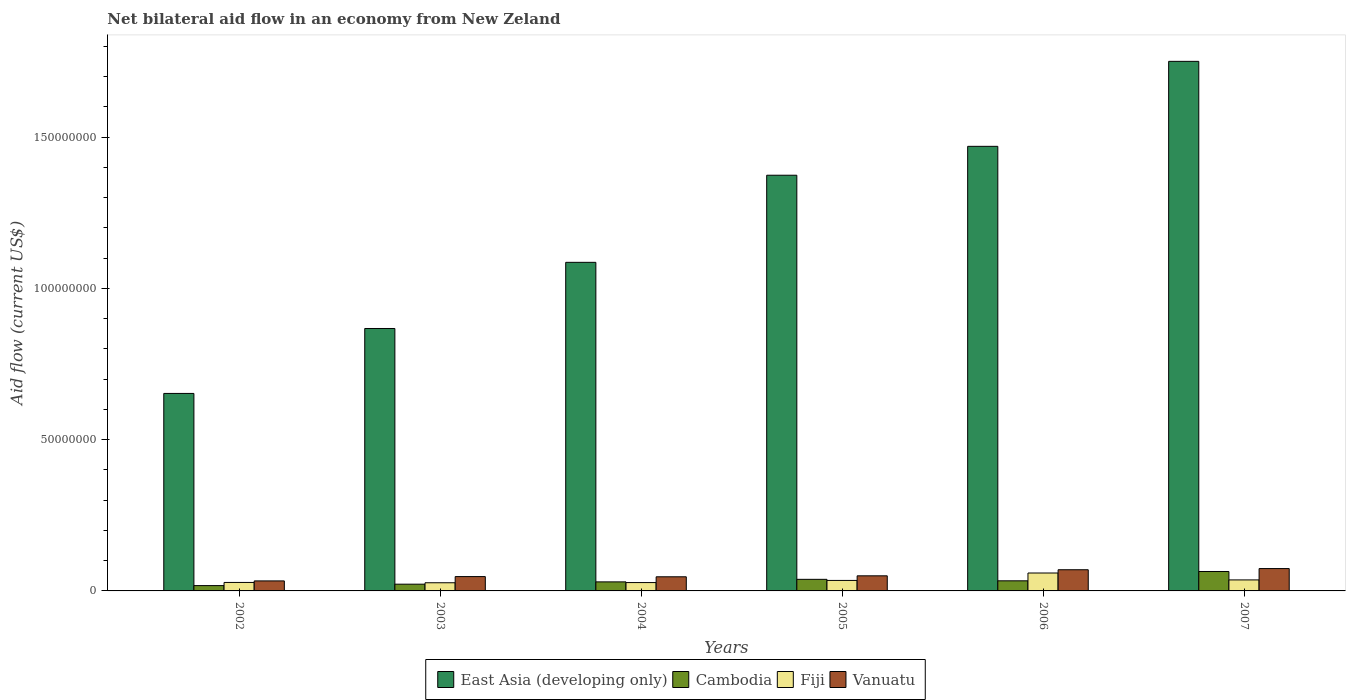How many different coloured bars are there?
Offer a very short reply. 4. How many bars are there on the 5th tick from the right?
Ensure brevity in your answer.  4. What is the label of the 4th group of bars from the left?
Provide a short and direct response. 2005. What is the net bilateral aid flow in Cambodia in 2002?
Your response must be concise. 1.76e+06. Across all years, what is the maximum net bilateral aid flow in East Asia (developing only)?
Ensure brevity in your answer.  1.75e+08. Across all years, what is the minimum net bilateral aid flow in Vanuatu?
Your answer should be very brief. 3.31e+06. In which year was the net bilateral aid flow in Fiji minimum?
Provide a succinct answer. 2003. What is the total net bilateral aid flow in Vanuatu in the graph?
Your answer should be compact. 3.21e+07. What is the difference between the net bilateral aid flow in Cambodia in 2003 and that in 2007?
Your answer should be compact. -4.19e+06. What is the difference between the net bilateral aid flow in East Asia (developing only) in 2002 and the net bilateral aid flow in Fiji in 2004?
Provide a short and direct response. 6.25e+07. What is the average net bilateral aid flow in East Asia (developing only) per year?
Your response must be concise. 1.20e+08. In how many years, is the net bilateral aid flow in Cambodia greater than 110000000 US$?
Your answer should be very brief. 0. What is the ratio of the net bilateral aid flow in East Asia (developing only) in 2002 to that in 2007?
Give a very brief answer. 0.37. What is the difference between the highest and the second highest net bilateral aid flow in East Asia (developing only)?
Give a very brief answer. 2.81e+07. What is the difference between the highest and the lowest net bilateral aid flow in Vanuatu?
Keep it short and to the point. 4.08e+06. In how many years, is the net bilateral aid flow in Fiji greater than the average net bilateral aid flow in Fiji taken over all years?
Keep it short and to the point. 2. Is the sum of the net bilateral aid flow in Cambodia in 2002 and 2003 greater than the maximum net bilateral aid flow in Fiji across all years?
Provide a short and direct response. No. What does the 3rd bar from the left in 2004 represents?
Give a very brief answer. Fiji. What does the 2nd bar from the right in 2007 represents?
Ensure brevity in your answer.  Fiji. How many bars are there?
Provide a succinct answer. 24. Are all the bars in the graph horizontal?
Ensure brevity in your answer.  No. What is the difference between two consecutive major ticks on the Y-axis?
Provide a succinct answer. 5.00e+07. Are the values on the major ticks of Y-axis written in scientific E-notation?
Your answer should be compact. No. Does the graph contain any zero values?
Ensure brevity in your answer.  No. Does the graph contain grids?
Your answer should be compact. No. How many legend labels are there?
Your answer should be compact. 4. What is the title of the graph?
Ensure brevity in your answer.  Net bilateral aid flow in an economy from New Zeland. What is the label or title of the X-axis?
Provide a succinct answer. Years. What is the Aid flow (current US$) of East Asia (developing only) in 2002?
Your response must be concise. 6.53e+07. What is the Aid flow (current US$) of Cambodia in 2002?
Your response must be concise. 1.76e+06. What is the Aid flow (current US$) of Fiji in 2002?
Give a very brief answer. 2.80e+06. What is the Aid flow (current US$) in Vanuatu in 2002?
Offer a terse response. 3.31e+06. What is the Aid flow (current US$) in East Asia (developing only) in 2003?
Your answer should be compact. 8.67e+07. What is the Aid flow (current US$) in Cambodia in 2003?
Your answer should be very brief. 2.23e+06. What is the Aid flow (current US$) of Fiji in 2003?
Your answer should be very brief. 2.70e+06. What is the Aid flow (current US$) in Vanuatu in 2003?
Your answer should be compact. 4.74e+06. What is the Aid flow (current US$) in East Asia (developing only) in 2004?
Give a very brief answer. 1.09e+08. What is the Aid flow (current US$) of Cambodia in 2004?
Provide a succinct answer. 2.99e+06. What is the Aid flow (current US$) of Fiji in 2004?
Your answer should be compact. 2.76e+06. What is the Aid flow (current US$) in Vanuatu in 2004?
Your answer should be very brief. 4.67e+06. What is the Aid flow (current US$) in East Asia (developing only) in 2005?
Make the answer very short. 1.37e+08. What is the Aid flow (current US$) of Cambodia in 2005?
Your answer should be very brief. 3.83e+06. What is the Aid flow (current US$) of Fiji in 2005?
Provide a short and direct response. 3.47e+06. What is the Aid flow (current US$) of Vanuatu in 2005?
Offer a terse response. 4.99e+06. What is the Aid flow (current US$) of East Asia (developing only) in 2006?
Your answer should be compact. 1.47e+08. What is the Aid flow (current US$) in Cambodia in 2006?
Your response must be concise. 3.34e+06. What is the Aid flow (current US$) of Fiji in 2006?
Make the answer very short. 5.92e+06. What is the Aid flow (current US$) in Vanuatu in 2006?
Give a very brief answer. 7.00e+06. What is the Aid flow (current US$) in East Asia (developing only) in 2007?
Give a very brief answer. 1.75e+08. What is the Aid flow (current US$) in Cambodia in 2007?
Offer a terse response. 6.42e+06. What is the Aid flow (current US$) in Fiji in 2007?
Offer a terse response. 3.64e+06. What is the Aid flow (current US$) in Vanuatu in 2007?
Offer a terse response. 7.39e+06. Across all years, what is the maximum Aid flow (current US$) of East Asia (developing only)?
Offer a terse response. 1.75e+08. Across all years, what is the maximum Aid flow (current US$) of Cambodia?
Give a very brief answer. 6.42e+06. Across all years, what is the maximum Aid flow (current US$) of Fiji?
Your answer should be compact. 5.92e+06. Across all years, what is the maximum Aid flow (current US$) in Vanuatu?
Your answer should be compact. 7.39e+06. Across all years, what is the minimum Aid flow (current US$) in East Asia (developing only)?
Provide a succinct answer. 6.53e+07. Across all years, what is the minimum Aid flow (current US$) of Cambodia?
Your response must be concise. 1.76e+06. Across all years, what is the minimum Aid flow (current US$) in Fiji?
Make the answer very short. 2.70e+06. Across all years, what is the minimum Aid flow (current US$) in Vanuatu?
Offer a terse response. 3.31e+06. What is the total Aid flow (current US$) of East Asia (developing only) in the graph?
Provide a succinct answer. 7.20e+08. What is the total Aid flow (current US$) in Cambodia in the graph?
Your response must be concise. 2.06e+07. What is the total Aid flow (current US$) in Fiji in the graph?
Provide a short and direct response. 2.13e+07. What is the total Aid flow (current US$) in Vanuatu in the graph?
Your answer should be compact. 3.21e+07. What is the difference between the Aid flow (current US$) of East Asia (developing only) in 2002 and that in 2003?
Provide a succinct answer. -2.15e+07. What is the difference between the Aid flow (current US$) in Cambodia in 2002 and that in 2003?
Make the answer very short. -4.70e+05. What is the difference between the Aid flow (current US$) in Vanuatu in 2002 and that in 2003?
Ensure brevity in your answer.  -1.43e+06. What is the difference between the Aid flow (current US$) of East Asia (developing only) in 2002 and that in 2004?
Provide a succinct answer. -4.33e+07. What is the difference between the Aid flow (current US$) in Cambodia in 2002 and that in 2004?
Provide a short and direct response. -1.23e+06. What is the difference between the Aid flow (current US$) in Vanuatu in 2002 and that in 2004?
Ensure brevity in your answer.  -1.36e+06. What is the difference between the Aid flow (current US$) in East Asia (developing only) in 2002 and that in 2005?
Provide a succinct answer. -7.21e+07. What is the difference between the Aid flow (current US$) of Cambodia in 2002 and that in 2005?
Ensure brevity in your answer.  -2.07e+06. What is the difference between the Aid flow (current US$) of Fiji in 2002 and that in 2005?
Give a very brief answer. -6.70e+05. What is the difference between the Aid flow (current US$) of Vanuatu in 2002 and that in 2005?
Offer a terse response. -1.68e+06. What is the difference between the Aid flow (current US$) in East Asia (developing only) in 2002 and that in 2006?
Your answer should be compact. -8.17e+07. What is the difference between the Aid flow (current US$) of Cambodia in 2002 and that in 2006?
Your answer should be very brief. -1.58e+06. What is the difference between the Aid flow (current US$) of Fiji in 2002 and that in 2006?
Provide a short and direct response. -3.12e+06. What is the difference between the Aid flow (current US$) in Vanuatu in 2002 and that in 2006?
Ensure brevity in your answer.  -3.69e+06. What is the difference between the Aid flow (current US$) in East Asia (developing only) in 2002 and that in 2007?
Ensure brevity in your answer.  -1.10e+08. What is the difference between the Aid flow (current US$) of Cambodia in 2002 and that in 2007?
Provide a short and direct response. -4.66e+06. What is the difference between the Aid flow (current US$) in Fiji in 2002 and that in 2007?
Offer a very short reply. -8.40e+05. What is the difference between the Aid flow (current US$) in Vanuatu in 2002 and that in 2007?
Ensure brevity in your answer.  -4.08e+06. What is the difference between the Aid flow (current US$) of East Asia (developing only) in 2003 and that in 2004?
Make the answer very short. -2.19e+07. What is the difference between the Aid flow (current US$) of Cambodia in 2003 and that in 2004?
Make the answer very short. -7.60e+05. What is the difference between the Aid flow (current US$) of Fiji in 2003 and that in 2004?
Ensure brevity in your answer.  -6.00e+04. What is the difference between the Aid flow (current US$) in East Asia (developing only) in 2003 and that in 2005?
Provide a succinct answer. -5.07e+07. What is the difference between the Aid flow (current US$) of Cambodia in 2003 and that in 2005?
Offer a very short reply. -1.60e+06. What is the difference between the Aid flow (current US$) of Fiji in 2003 and that in 2005?
Your answer should be compact. -7.70e+05. What is the difference between the Aid flow (current US$) of East Asia (developing only) in 2003 and that in 2006?
Provide a short and direct response. -6.02e+07. What is the difference between the Aid flow (current US$) of Cambodia in 2003 and that in 2006?
Offer a terse response. -1.11e+06. What is the difference between the Aid flow (current US$) of Fiji in 2003 and that in 2006?
Offer a terse response. -3.22e+06. What is the difference between the Aid flow (current US$) of Vanuatu in 2003 and that in 2006?
Keep it short and to the point. -2.26e+06. What is the difference between the Aid flow (current US$) in East Asia (developing only) in 2003 and that in 2007?
Offer a terse response. -8.83e+07. What is the difference between the Aid flow (current US$) of Cambodia in 2003 and that in 2007?
Offer a very short reply. -4.19e+06. What is the difference between the Aid flow (current US$) in Fiji in 2003 and that in 2007?
Keep it short and to the point. -9.40e+05. What is the difference between the Aid flow (current US$) of Vanuatu in 2003 and that in 2007?
Your answer should be very brief. -2.65e+06. What is the difference between the Aid flow (current US$) of East Asia (developing only) in 2004 and that in 2005?
Your answer should be compact. -2.88e+07. What is the difference between the Aid flow (current US$) of Cambodia in 2004 and that in 2005?
Give a very brief answer. -8.40e+05. What is the difference between the Aid flow (current US$) in Fiji in 2004 and that in 2005?
Provide a succinct answer. -7.10e+05. What is the difference between the Aid flow (current US$) in Vanuatu in 2004 and that in 2005?
Ensure brevity in your answer.  -3.20e+05. What is the difference between the Aid flow (current US$) of East Asia (developing only) in 2004 and that in 2006?
Give a very brief answer. -3.83e+07. What is the difference between the Aid flow (current US$) of Cambodia in 2004 and that in 2006?
Your response must be concise. -3.50e+05. What is the difference between the Aid flow (current US$) of Fiji in 2004 and that in 2006?
Offer a terse response. -3.16e+06. What is the difference between the Aid flow (current US$) of Vanuatu in 2004 and that in 2006?
Give a very brief answer. -2.33e+06. What is the difference between the Aid flow (current US$) of East Asia (developing only) in 2004 and that in 2007?
Offer a terse response. -6.64e+07. What is the difference between the Aid flow (current US$) in Cambodia in 2004 and that in 2007?
Provide a succinct answer. -3.43e+06. What is the difference between the Aid flow (current US$) of Fiji in 2004 and that in 2007?
Offer a very short reply. -8.80e+05. What is the difference between the Aid flow (current US$) of Vanuatu in 2004 and that in 2007?
Give a very brief answer. -2.72e+06. What is the difference between the Aid flow (current US$) of East Asia (developing only) in 2005 and that in 2006?
Your response must be concise. -9.55e+06. What is the difference between the Aid flow (current US$) in Cambodia in 2005 and that in 2006?
Offer a very short reply. 4.90e+05. What is the difference between the Aid flow (current US$) of Fiji in 2005 and that in 2006?
Your response must be concise. -2.45e+06. What is the difference between the Aid flow (current US$) of Vanuatu in 2005 and that in 2006?
Offer a very short reply. -2.01e+06. What is the difference between the Aid flow (current US$) in East Asia (developing only) in 2005 and that in 2007?
Your response must be concise. -3.76e+07. What is the difference between the Aid flow (current US$) in Cambodia in 2005 and that in 2007?
Your answer should be compact. -2.59e+06. What is the difference between the Aid flow (current US$) of Fiji in 2005 and that in 2007?
Your answer should be compact. -1.70e+05. What is the difference between the Aid flow (current US$) in Vanuatu in 2005 and that in 2007?
Your response must be concise. -2.40e+06. What is the difference between the Aid flow (current US$) in East Asia (developing only) in 2006 and that in 2007?
Give a very brief answer. -2.81e+07. What is the difference between the Aid flow (current US$) of Cambodia in 2006 and that in 2007?
Your answer should be compact. -3.08e+06. What is the difference between the Aid flow (current US$) of Fiji in 2006 and that in 2007?
Give a very brief answer. 2.28e+06. What is the difference between the Aid flow (current US$) in Vanuatu in 2006 and that in 2007?
Your response must be concise. -3.90e+05. What is the difference between the Aid flow (current US$) of East Asia (developing only) in 2002 and the Aid flow (current US$) of Cambodia in 2003?
Your answer should be compact. 6.30e+07. What is the difference between the Aid flow (current US$) of East Asia (developing only) in 2002 and the Aid flow (current US$) of Fiji in 2003?
Your answer should be very brief. 6.26e+07. What is the difference between the Aid flow (current US$) of East Asia (developing only) in 2002 and the Aid flow (current US$) of Vanuatu in 2003?
Keep it short and to the point. 6.05e+07. What is the difference between the Aid flow (current US$) of Cambodia in 2002 and the Aid flow (current US$) of Fiji in 2003?
Keep it short and to the point. -9.40e+05. What is the difference between the Aid flow (current US$) in Cambodia in 2002 and the Aid flow (current US$) in Vanuatu in 2003?
Make the answer very short. -2.98e+06. What is the difference between the Aid flow (current US$) of Fiji in 2002 and the Aid flow (current US$) of Vanuatu in 2003?
Your answer should be compact. -1.94e+06. What is the difference between the Aid flow (current US$) of East Asia (developing only) in 2002 and the Aid flow (current US$) of Cambodia in 2004?
Offer a very short reply. 6.23e+07. What is the difference between the Aid flow (current US$) in East Asia (developing only) in 2002 and the Aid flow (current US$) in Fiji in 2004?
Give a very brief answer. 6.25e+07. What is the difference between the Aid flow (current US$) in East Asia (developing only) in 2002 and the Aid flow (current US$) in Vanuatu in 2004?
Ensure brevity in your answer.  6.06e+07. What is the difference between the Aid flow (current US$) in Cambodia in 2002 and the Aid flow (current US$) in Vanuatu in 2004?
Ensure brevity in your answer.  -2.91e+06. What is the difference between the Aid flow (current US$) in Fiji in 2002 and the Aid flow (current US$) in Vanuatu in 2004?
Keep it short and to the point. -1.87e+06. What is the difference between the Aid flow (current US$) of East Asia (developing only) in 2002 and the Aid flow (current US$) of Cambodia in 2005?
Provide a succinct answer. 6.14e+07. What is the difference between the Aid flow (current US$) in East Asia (developing only) in 2002 and the Aid flow (current US$) in Fiji in 2005?
Your answer should be very brief. 6.18e+07. What is the difference between the Aid flow (current US$) in East Asia (developing only) in 2002 and the Aid flow (current US$) in Vanuatu in 2005?
Provide a short and direct response. 6.03e+07. What is the difference between the Aid flow (current US$) in Cambodia in 2002 and the Aid flow (current US$) in Fiji in 2005?
Offer a very short reply. -1.71e+06. What is the difference between the Aid flow (current US$) of Cambodia in 2002 and the Aid flow (current US$) of Vanuatu in 2005?
Offer a very short reply. -3.23e+06. What is the difference between the Aid flow (current US$) of Fiji in 2002 and the Aid flow (current US$) of Vanuatu in 2005?
Your answer should be very brief. -2.19e+06. What is the difference between the Aid flow (current US$) of East Asia (developing only) in 2002 and the Aid flow (current US$) of Cambodia in 2006?
Make the answer very short. 6.19e+07. What is the difference between the Aid flow (current US$) of East Asia (developing only) in 2002 and the Aid flow (current US$) of Fiji in 2006?
Ensure brevity in your answer.  5.94e+07. What is the difference between the Aid flow (current US$) in East Asia (developing only) in 2002 and the Aid flow (current US$) in Vanuatu in 2006?
Offer a terse response. 5.83e+07. What is the difference between the Aid flow (current US$) of Cambodia in 2002 and the Aid flow (current US$) of Fiji in 2006?
Provide a succinct answer. -4.16e+06. What is the difference between the Aid flow (current US$) in Cambodia in 2002 and the Aid flow (current US$) in Vanuatu in 2006?
Provide a short and direct response. -5.24e+06. What is the difference between the Aid flow (current US$) of Fiji in 2002 and the Aid flow (current US$) of Vanuatu in 2006?
Provide a succinct answer. -4.20e+06. What is the difference between the Aid flow (current US$) of East Asia (developing only) in 2002 and the Aid flow (current US$) of Cambodia in 2007?
Give a very brief answer. 5.89e+07. What is the difference between the Aid flow (current US$) in East Asia (developing only) in 2002 and the Aid flow (current US$) in Fiji in 2007?
Your response must be concise. 6.16e+07. What is the difference between the Aid flow (current US$) of East Asia (developing only) in 2002 and the Aid flow (current US$) of Vanuatu in 2007?
Offer a very short reply. 5.79e+07. What is the difference between the Aid flow (current US$) in Cambodia in 2002 and the Aid flow (current US$) in Fiji in 2007?
Offer a terse response. -1.88e+06. What is the difference between the Aid flow (current US$) of Cambodia in 2002 and the Aid flow (current US$) of Vanuatu in 2007?
Keep it short and to the point. -5.63e+06. What is the difference between the Aid flow (current US$) of Fiji in 2002 and the Aid flow (current US$) of Vanuatu in 2007?
Offer a very short reply. -4.59e+06. What is the difference between the Aid flow (current US$) of East Asia (developing only) in 2003 and the Aid flow (current US$) of Cambodia in 2004?
Make the answer very short. 8.38e+07. What is the difference between the Aid flow (current US$) of East Asia (developing only) in 2003 and the Aid flow (current US$) of Fiji in 2004?
Make the answer very short. 8.40e+07. What is the difference between the Aid flow (current US$) of East Asia (developing only) in 2003 and the Aid flow (current US$) of Vanuatu in 2004?
Make the answer very short. 8.21e+07. What is the difference between the Aid flow (current US$) in Cambodia in 2003 and the Aid flow (current US$) in Fiji in 2004?
Keep it short and to the point. -5.30e+05. What is the difference between the Aid flow (current US$) in Cambodia in 2003 and the Aid flow (current US$) in Vanuatu in 2004?
Offer a terse response. -2.44e+06. What is the difference between the Aid flow (current US$) of Fiji in 2003 and the Aid flow (current US$) of Vanuatu in 2004?
Your answer should be compact. -1.97e+06. What is the difference between the Aid flow (current US$) of East Asia (developing only) in 2003 and the Aid flow (current US$) of Cambodia in 2005?
Offer a very short reply. 8.29e+07. What is the difference between the Aid flow (current US$) of East Asia (developing only) in 2003 and the Aid flow (current US$) of Fiji in 2005?
Your answer should be very brief. 8.33e+07. What is the difference between the Aid flow (current US$) in East Asia (developing only) in 2003 and the Aid flow (current US$) in Vanuatu in 2005?
Ensure brevity in your answer.  8.18e+07. What is the difference between the Aid flow (current US$) of Cambodia in 2003 and the Aid flow (current US$) of Fiji in 2005?
Offer a terse response. -1.24e+06. What is the difference between the Aid flow (current US$) in Cambodia in 2003 and the Aid flow (current US$) in Vanuatu in 2005?
Provide a succinct answer. -2.76e+06. What is the difference between the Aid flow (current US$) in Fiji in 2003 and the Aid flow (current US$) in Vanuatu in 2005?
Offer a terse response. -2.29e+06. What is the difference between the Aid flow (current US$) in East Asia (developing only) in 2003 and the Aid flow (current US$) in Cambodia in 2006?
Provide a succinct answer. 8.34e+07. What is the difference between the Aid flow (current US$) of East Asia (developing only) in 2003 and the Aid flow (current US$) of Fiji in 2006?
Provide a short and direct response. 8.08e+07. What is the difference between the Aid flow (current US$) of East Asia (developing only) in 2003 and the Aid flow (current US$) of Vanuatu in 2006?
Offer a very short reply. 7.97e+07. What is the difference between the Aid flow (current US$) of Cambodia in 2003 and the Aid flow (current US$) of Fiji in 2006?
Keep it short and to the point. -3.69e+06. What is the difference between the Aid flow (current US$) in Cambodia in 2003 and the Aid flow (current US$) in Vanuatu in 2006?
Offer a very short reply. -4.77e+06. What is the difference between the Aid flow (current US$) in Fiji in 2003 and the Aid flow (current US$) in Vanuatu in 2006?
Your answer should be compact. -4.30e+06. What is the difference between the Aid flow (current US$) of East Asia (developing only) in 2003 and the Aid flow (current US$) of Cambodia in 2007?
Offer a terse response. 8.03e+07. What is the difference between the Aid flow (current US$) in East Asia (developing only) in 2003 and the Aid flow (current US$) in Fiji in 2007?
Make the answer very short. 8.31e+07. What is the difference between the Aid flow (current US$) of East Asia (developing only) in 2003 and the Aid flow (current US$) of Vanuatu in 2007?
Your answer should be very brief. 7.94e+07. What is the difference between the Aid flow (current US$) in Cambodia in 2003 and the Aid flow (current US$) in Fiji in 2007?
Provide a short and direct response. -1.41e+06. What is the difference between the Aid flow (current US$) of Cambodia in 2003 and the Aid flow (current US$) of Vanuatu in 2007?
Offer a terse response. -5.16e+06. What is the difference between the Aid flow (current US$) in Fiji in 2003 and the Aid flow (current US$) in Vanuatu in 2007?
Make the answer very short. -4.69e+06. What is the difference between the Aid flow (current US$) of East Asia (developing only) in 2004 and the Aid flow (current US$) of Cambodia in 2005?
Make the answer very short. 1.05e+08. What is the difference between the Aid flow (current US$) of East Asia (developing only) in 2004 and the Aid flow (current US$) of Fiji in 2005?
Ensure brevity in your answer.  1.05e+08. What is the difference between the Aid flow (current US$) in East Asia (developing only) in 2004 and the Aid flow (current US$) in Vanuatu in 2005?
Ensure brevity in your answer.  1.04e+08. What is the difference between the Aid flow (current US$) in Cambodia in 2004 and the Aid flow (current US$) in Fiji in 2005?
Ensure brevity in your answer.  -4.80e+05. What is the difference between the Aid flow (current US$) in Fiji in 2004 and the Aid flow (current US$) in Vanuatu in 2005?
Provide a succinct answer. -2.23e+06. What is the difference between the Aid flow (current US$) in East Asia (developing only) in 2004 and the Aid flow (current US$) in Cambodia in 2006?
Your answer should be very brief. 1.05e+08. What is the difference between the Aid flow (current US$) in East Asia (developing only) in 2004 and the Aid flow (current US$) in Fiji in 2006?
Keep it short and to the point. 1.03e+08. What is the difference between the Aid flow (current US$) of East Asia (developing only) in 2004 and the Aid flow (current US$) of Vanuatu in 2006?
Make the answer very short. 1.02e+08. What is the difference between the Aid flow (current US$) of Cambodia in 2004 and the Aid flow (current US$) of Fiji in 2006?
Offer a terse response. -2.93e+06. What is the difference between the Aid flow (current US$) of Cambodia in 2004 and the Aid flow (current US$) of Vanuatu in 2006?
Provide a short and direct response. -4.01e+06. What is the difference between the Aid flow (current US$) of Fiji in 2004 and the Aid flow (current US$) of Vanuatu in 2006?
Your answer should be compact. -4.24e+06. What is the difference between the Aid flow (current US$) in East Asia (developing only) in 2004 and the Aid flow (current US$) in Cambodia in 2007?
Provide a short and direct response. 1.02e+08. What is the difference between the Aid flow (current US$) in East Asia (developing only) in 2004 and the Aid flow (current US$) in Fiji in 2007?
Your answer should be compact. 1.05e+08. What is the difference between the Aid flow (current US$) in East Asia (developing only) in 2004 and the Aid flow (current US$) in Vanuatu in 2007?
Ensure brevity in your answer.  1.01e+08. What is the difference between the Aid flow (current US$) of Cambodia in 2004 and the Aid flow (current US$) of Fiji in 2007?
Offer a terse response. -6.50e+05. What is the difference between the Aid flow (current US$) of Cambodia in 2004 and the Aid flow (current US$) of Vanuatu in 2007?
Offer a very short reply. -4.40e+06. What is the difference between the Aid flow (current US$) of Fiji in 2004 and the Aid flow (current US$) of Vanuatu in 2007?
Your answer should be very brief. -4.63e+06. What is the difference between the Aid flow (current US$) in East Asia (developing only) in 2005 and the Aid flow (current US$) in Cambodia in 2006?
Ensure brevity in your answer.  1.34e+08. What is the difference between the Aid flow (current US$) of East Asia (developing only) in 2005 and the Aid flow (current US$) of Fiji in 2006?
Offer a very short reply. 1.31e+08. What is the difference between the Aid flow (current US$) of East Asia (developing only) in 2005 and the Aid flow (current US$) of Vanuatu in 2006?
Offer a terse response. 1.30e+08. What is the difference between the Aid flow (current US$) in Cambodia in 2005 and the Aid flow (current US$) in Fiji in 2006?
Offer a terse response. -2.09e+06. What is the difference between the Aid flow (current US$) in Cambodia in 2005 and the Aid flow (current US$) in Vanuatu in 2006?
Ensure brevity in your answer.  -3.17e+06. What is the difference between the Aid flow (current US$) of Fiji in 2005 and the Aid flow (current US$) of Vanuatu in 2006?
Your answer should be very brief. -3.53e+06. What is the difference between the Aid flow (current US$) in East Asia (developing only) in 2005 and the Aid flow (current US$) in Cambodia in 2007?
Your answer should be compact. 1.31e+08. What is the difference between the Aid flow (current US$) of East Asia (developing only) in 2005 and the Aid flow (current US$) of Fiji in 2007?
Offer a very short reply. 1.34e+08. What is the difference between the Aid flow (current US$) in East Asia (developing only) in 2005 and the Aid flow (current US$) in Vanuatu in 2007?
Provide a succinct answer. 1.30e+08. What is the difference between the Aid flow (current US$) of Cambodia in 2005 and the Aid flow (current US$) of Vanuatu in 2007?
Your answer should be compact. -3.56e+06. What is the difference between the Aid flow (current US$) in Fiji in 2005 and the Aid flow (current US$) in Vanuatu in 2007?
Ensure brevity in your answer.  -3.92e+06. What is the difference between the Aid flow (current US$) of East Asia (developing only) in 2006 and the Aid flow (current US$) of Cambodia in 2007?
Your response must be concise. 1.41e+08. What is the difference between the Aid flow (current US$) of East Asia (developing only) in 2006 and the Aid flow (current US$) of Fiji in 2007?
Give a very brief answer. 1.43e+08. What is the difference between the Aid flow (current US$) in East Asia (developing only) in 2006 and the Aid flow (current US$) in Vanuatu in 2007?
Provide a short and direct response. 1.40e+08. What is the difference between the Aid flow (current US$) in Cambodia in 2006 and the Aid flow (current US$) in Fiji in 2007?
Keep it short and to the point. -3.00e+05. What is the difference between the Aid flow (current US$) in Cambodia in 2006 and the Aid flow (current US$) in Vanuatu in 2007?
Provide a short and direct response. -4.05e+06. What is the difference between the Aid flow (current US$) in Fiji in 2006 and the Aid flow (current US$) in Vanuatu in 2007?
Offer a very short reply. -1.47e+06. What is the average Aid flow (current US$) of East Asia (developing only) per year?
Ensure brevity in your answer.  1.20e+08. What is the average Aid flow (current US$) in Cambodia per year?
Keep it short and to the point. 3.43e+06. What is the average Aid flow (current US$) in Fiji per year?
Make the answer very short. 3.55e+06. What is the average Aid flow (current US$) in Vanuatu per year?
Keep it short and to the point. 5.35e+06. In the year 2002, what is the difference between the Aid flow (current US$) in East Asia (developing only) and Aid flow (current US$) in Cambodia?
Your response must be concise. 6.35e+07. In the year 2002, what is the difference between the Aid flow (current US$) of East Asia (developing only) and Aid flow (current US$) of Fiji?
Your response must be concise. 6.25e+07. In the year 2002, what is the difference between the Aid flow (current US$) in East Asia (developing only) and Aid flow (current US$) in Vanuatu?
Provide a succinct answer. 6.20e+07. In the year 2002, what is the difference between the Aid flow (current US$) in Cambodia and Aid flow (current US$) in Fiji?
Offer a terse response. -1.04e+06. In the year 2002, what is the difference between the Aid flow (current US$) in Cambodia and Aid flow (current US$) in Vanuatu?
Offer a very short reply. -1.55e+06. In the year 2002, what is the difference between the Aid flow (current US$) of Fiji and Aid flow (current US$) of Vanuatu?
Provide a succinct answer. -5.10e+05. In the year 2003, what is the difference between the Aid flow (current US$) in East Asia (developing only) and Aid flow (current US$) in Cambodia?
Your answer should be very brief. 8.45e+07. In the year 2003, what is the difference between the Aid flow (current US$) in East Asia (developing only) and Aid flow (current US$) in Fiji?
Your answer should be compact. 8.40e+07. In the year 2003, what is the difference between the Aid flow (current US$) in East Asia (developing only) and Aid flow (current US$) in Vanuatu?
Your answer should be compact. 8.20e+07. In the year 2003, what is the difference between the Aid flow (current US$) in Cambodia and Aid flow (current US$) in Fiji?
Provide a succinct answer. -4.70e+05. In the year 2003, what is the difference between the Aid flow (current US$) in Cambodia and Aid flow (current US$) in Vanuatu?
Ensure brevity in your answer.  -2.51e+06. In the year 2003, what is the difference between the Aid flow (current US$) of Fiji and Aid flow (current US$) of Vanuatu?
Ensure brevity in your answer.  -2.04e+06. In the year 2004, what is the difference between the Aid flow (current US$) in East Asia (developing only) and Aid flow (current US$) in Cambodia?
Make the answer very short. 1.06e+08. In the year 2004, what is the difference between the Aid flow (current US$) in East Asia (developing only) and Aid flow (current US$) in Fiji?
Provide a short and direct response. 1.06e+08. In the year 2004, what is the difference between the Aid flow (current US$) of East Asia (developing only) and Aid flow (current US$) of Vanuatu?
Make the answer very short. 1.04e+08. In the year 2004, what is the difference between the Aid flow (current US$) of Cambodia and Aid flow (current US$) of Vanuatu?
Give a very brief answer. -1.68e+06. In the year 2004, what is the difference between the Aid flow (current US$) in Fiji and Aid flow (current US$) in Vanuatu?
Your answer should be very brief. -1.91e+06. In the year 2005, what is the difference between the Aid flow (current US$) of East Asia (developing only) and Aid flow (current US$) of Cambodia?
Give a very brief answer. 1.34e+08. In the year 2005, what is the difference between the Aid flow (current US$) of East Asia (developing only) and Aid flow (current US$) of Fiji?
Give a very brief answer. 1.34e+08. In the year 2005, what is the difference between the Aid flow (current US$) in East Asia (developing only) and Aid flow (current US$) in Vanuatu?
Offer a terse response. 1.32e+08. In the year 2005, what is the difference between the Aid flow (current US$) of Cambodia and Aid flow (current US$) of Fiji?
Offer a very short reply. 3.60e+05. In the year 2005, what is the difference between the Aid flow (current US$) of Cambodia and Aid flow (current US$) of Vanuatu?
Your response must be concise. -1.16e+06. In the year 2005, what is the difference between the Aid flow (current US$) of Fiji and Aid flow (current US$) of Vanuatu?
Offer a terse response. -1.52e+06. In the year 2006, what is the difference between the Aid flow (current US$) of East Asia (developing only) and Aid flow (current US$) of Cambodia?
Provide a short and direct response. 1.44e+08. In the year 2006, what is the difference between the Aid flow (current US$) of East Asia (developing only) and Aid flow (current US$) of Fiji?
Offer a very short reply. 1.41e+08. In the year 2006, what is the difference between the Aid flow (current US$) in East Asia (developing only) and Aid flow (current US$) in Vanuatu?
Provide a short and direct response. 1.40e+08. In the year 2006, what is the difference between the Aid flow (current US$) in Cambodia and Aid flow (current US$) in Fiji?
Give a very brief answer. -2.58e+06. In the year 2006, what is the difference between the Aid flow (current US$) in Cambodia and Aid flow (current US$) in Vanuatu?
Your answer should be compact. -3.66e+06. In the year 2006, what is the difference between the Aid flow (current US$) of Fiji and Aid flow (current US$) of Vanuatu?
Offer a very short reply. -1.08e+06. In the year 2007, what is the difference between the Aid flow (current US$) of East Asia (developing only) and Aid flow (current US$) of Cambodia?
Provide a short and direct response. 1.69e+08. In the year 2007, what is the difference between the Aid flow (current US$) of East Asia (developing only) and Aid flow (current US$) of Fiji?
Offer a terse response. 1.71e+08. In the year 2007, what is the difference between the Aid flow (current US$) in East Asia (developing only) and Aid flow (current US$) in Vanuatu?
Provide a short and direct response. 1.68e+08. In the year 2007, what is the difference between the Aid flow (current US$) in Cambodia and Aid flow (current US$) in Fiji?
Your response must be concise. 2.78e+06. In the year 2007, what is the difference between the Aid flow (current US$) in Cambodia and Aid flow (current US$) in Vanuatu?
Provide a short and direct response. -9.70e+05. In the year 2007, what is the difference between the Aid flow (current US$) of Fiji and Aid flow (current US$) of Vanuatu?
Give a very brief answer. -3.75e+06. What is the ratio of the Aid flow (current US$) in East Asia (developing only) in 2002 to that in 2003?
Ensure brevity in your answer.  0.75. What is the ratio of the Aid flow (current US$) of Cambodia in 2002 to that in 2003?
Keep it short and to the point. 0.79. What is the ratio of the Aid flow (current US$) in Vanuatu in 2002 to that in 2003?
Keep it short and to the point. 0.7. What is the ratio of the Aid flow (current US$) in East Asia (developing only) in 2002 to that in 2004?
Provide a short and direct response. 0.6. What is the ratio of the Aid flow (current US$) of Cambodia in 2002 to that in 2004?
Your response must be concise. 0.59. What is the ratio of the Aid flow (current US$) in Fiji in 2002 to that in 2004?
Your answer should be very brief. 1.01. What is the ratio of the Aid flow (current US$) of Vanuatu in 2002 to that in 2004?
Ensure brevity in your answer.  0.71. What is the ratio of the Aid flow (current US$) of East Asia (developing only) in 2002 to that in 2005?
Give a very brief answer. 0.48. What is the ratio of the Aid flow (current US$) in Cambodia in 2002 to that in 2005?
Offer a very short reply. 0.46. What is the ratio of the Aid flow (current US$) in Fiji in 2002 to that in 2005?
Ensure brevity in your answer.  0.81. What is the ratio of the Aid flow (current US$) of Vanuatu in 2002 to that in 2005?
Ensure brevity in your answer.  0.66. What is the ratio of the Aid flow (current US$) of East Asia (developing only) in 2002 to that in 2006?
Give a very brief answer. 0.44. What is the ratio of the Aid flow (current US$) in Cambodia in 2002 to that in 2006?
Provide a succinct answer. 0.53. What is the ratio of the Aid flow (current US$) in Fiji in 2002 to that in 2006?
Ensure brevity in your answer.  0.47. What is the ratio of the Aid flow (current US$) in Vanuatu in 2002 to that in 2006?
Offer a very short reply. 0.47. What is the ratio of the Aid flow (current US$) of East Asia (developing only) in 2002 to that in 2007?
Your answer should be compact. 0.37. What is the ratio of the Aid flow (current US$) in Cambodia in 2002 to that in 2007?
Provide a short and direct response. 0.27. What is the ratio of the Aid flow (current US$) in Fiji in 2002 to that in 2007?
Your answer should be very brief. 0.77. What is the ratio of the Aid flow (current US$) of Vanuatu in 2002 to that in 2007?
Your answer should be compact. 0.45. What is the ratio of the Aid flow (current US$) of East Asia (developing only) in 2003 to that in 2004?
Offer a terse response. 0.8. What is the ratio of the Aid flow (current US$) of Cambodia in 2003 to that in 2004?
Ensure brevity in your answer.  0.75. What is the ratio of the Aid flow (current US$) of Fiji in 2003 to that in 2004?
Make the answer very short. 0.98. What is the ratio of the Aid flow (current US$) in East Asia (developing only) in 2003 to that in 2005?
Ensure brevity in your answer.  0.63. What is the ratio of the Aid flow (current US$) of Cambodia in 2003 to that in 2005?
Keep it short and to the point. 0.58. What is the ratio of the Aid flow (current US$) in Fiji in 2003 to that in 2005?
Keep it short and to the point. 0.78. What is the ratio of the Aid flow (current US$) in Vanuatu in 2003 to that in 2005?
Provide a short and direct response. 0.95. What is the ratio of the Aid flow (current US$) in East Asia (developing only) in 2003 to that in 2006?
Offer a terse response. 0.59. What is the ratio of the Aid flow (current US$) of Cambodia in 2003 to that in 2006?
Keep it short and to the point. 0.67. What is the ratio of the Aid flow (current US$) of Fiji in 2003 to that in 2006?
Keep it short and to the point. 0.46. What is the ratio of the Aid flow (current US$) in Vanuatu in 2003 to that in 2006?
Offer a very short reply. 0.68. What is the ratio of the Aid flow (current US$) of East Asia (developing only) in 2003 to that in 2007?
Your answer should be compact. 0.5. What is the ratio of the Aid flow (current US$) of Cambodia in 2003 to that in 2007?
Offer a terse response. 0.35. What is the ratio of the Aid flow (current US$) in Fiji in 2003 to that in 2007?
Provide a succinct answer. 0.74. What is the ratio of the Aid flow (current US$) in Vanuatu in 2003 to that in 2007?
Offer a terse response. 0.64. What is the ratio of the Aid flow (current US$) in East Asia (developing only) in 2004 to that in 2005?
Make the answer very short. 0.79. What is the ratio of the Aid flow (current US$) in Cambodia in 2004 to that in 2005?
Ensure brevity in your answer.  0.78. What is the ratio of the Aid flow (current US$) in Fiji in 2004 to that in 2005?
Keep it short and to the point. 0.8. What is the ratio of the Aid flow (current US$) of Vanuatu in 2004 to that in 2005?
Provide a succinct answer. 0.94. What is the ratio of the Aid flow (current US$) in East Asia (developing only) in 2004 to that in 2006?
Ensure brevity in your answer.  0.74. What is the ratio of the Aid flow (current US$) of Cambodia in 2004 to that in 2006?
Make the answer very short. 0.9. What is the ratio of the Aid flow (current US$) in Fiji in 2004 to that in 2006?
Keep it short and to the point. 0.47. What is the ratio of the Aid flow (current US$) of Vanuatu in 2004 to that in 2006?
Ensure brevity in your answer.  0.67. What is the ratio of the Aid flow (current US$) in East Asia (developing only) in 2004 to that in 2007?
Give a very brief answer. 0.62. What is the ratio of the Aid flow (current US$) of Cambodia in 2004 to that in 2007?
Your answer should be very brief. 0.47. What is the ratio of the Aid flow (current US$) of Fiji in 2004 to that in 2007?
Give a very brief answer. 0.76. What is the ratio of the Aid flow (current US$) of Vanuatu in 2004 to that in 2007?
Your answer should be very brief. 0.63. What is the ratio of the Aid flow (current US$) of East Asia (developing only) in 2005 to that in 2006?
Offer a terse response. 0.94. What is the ratio of the Aid flow (current US$) in Cambodia in 2005 to that in 2006?
Your answer should be compact. 1.15. What is the ratio of the Aid flow (current US$) of Fiji in 2005 to that in 2006?
Provide a succinct answer. 0.59. What is the ratio of the Aid flow (current US$) of Vanuatu in 2005 to that in 2006?
Your answer should be very brief. 0.71. What is the ratio of the Aid flow (current US$) of East Asia (developing only) in 2005 to that in 2007?
Make the answer very short. 0.79. What is the ratio of the Aid flow (current US$) of Cambodia in 2005 to that in 2007?
Your response must be concise. 0.6. What is the ratio of the Aid flow (current US$) in Fiji in 2005 to that in 2007?
Your answer should be compact. 0.95. What is the ratio of the Aid flow (current US$) of Vanuatu in 2005 to that in 2007?
Provide a short and direct response. 0.68. What is the ratio of the Aid flow (current US$) of East Asia (developing only) in 2006 to that in 2007?
Your response must be concise. 0.84. What is the ratio of the Aid flow (current US$) of Cambodia in 2006 to that in 2007?
Ensure brevity in your answer.  0.52. What is the ratio of the Aid flow (current US$) in Fiji in 2006 to that in 2007?
Offer a very short reply. 1.63. What is the ratio of the Aid flow (current US$) of Vanuatu in 2006 to that in 2007?
Keep it short and to the point. 0.95. What is the difference between the highest and the second highest Aid flow (current US$) of East Asia (developing only)?
Provide a succinct answer. 2.81e+07. What is the difference between the highest and the second highest Aid flow (current US$) in Cambodia?
Your answer should be very brief. 2.59e+06. What is the difference between the highest and the second highest Aid flow (current US$) in Fiji?
Offer a terse response. 2.28e+06. What is the difference between the highest and the second highest Aid flow (current US$) in Vanuatu?
Your answer should be very brief. 3.90e+05. What is the difference between the highest and the lowest Aid flow (current US$) of East Asia (developing only)?
Make the answer very short. 1.10e+08. What is the difference between the highest and the lowest Aid flow (current US$) in Cambodia?
Offer a terse response. 4.66e+06. What is the difference between the highest and the lowest Aid flow (current US$) in Fiji?
Provide a succinct answer. 3.22e+06. What is the difference between the highest and the lowest Aid flow (current US$) in Vanuatu?
Your answer should be compact. 4.08e+06. 